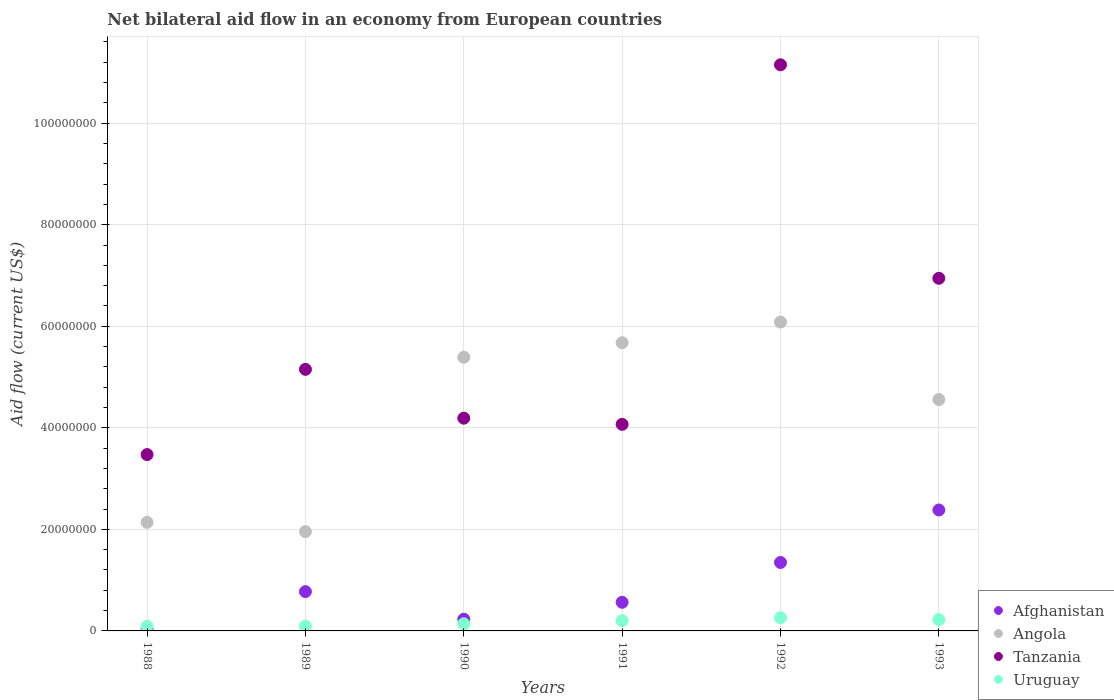Is the number of dotlines equal to the number of legend labels?
Offer a very short reply. Yes. What is the net bilateral aid flow in Angola in 1992?
Your answer should be compact. 6.08e+07. Across all years, what is the maximum net bilateral aid flow in Angola?
Provide a short and direct response. 6.08e+07. Across all years, what is the minimum net bilateral aid flow in Afghanistan?
Keep it short and to the point. 3.30e+05. In which year was the net bilateral aid flow in Uruguay minimum?
Offer a terse response. 1988. What is the total net bilateral aid flow in Angola in the graph?
Offer a very short reply. 2.58e+08. What is the difference between the net bilateral aid flow in Afghanistan in 1990 and that in 1991?
Provide a short and direct response. -3.34e+06. What is the difference between the net bilateral aid flow in Uruguay in 1988 and the net bilateral aid flow in Afghanistan in 1989?
Offer a terse response. -6.82e+06. What is the average net bilateral aid flow in Uruguay per year?
Provide a succinct answer. 1.68e+06. In the year 1992, what is the difference between the net bilateral aid flow in Angola and net bilateral aid flow in Tanzania?
Provide a succinct answer. -5.07e+07. In how many years, is the net bilateral aid flow in Tanzania greater than 28000000 US$?
Your answer should be very brief. 6. What is the ratio of the net bilateral aid flow in Tanzania in 1988 to that in 1992?
Your answer should be compact. 0.31. Is the net bilateral aid flow in Uruguay in 1992 less than that in 1993?
Your answer should be very brief. No. What is the difference between the highest and the second highest net bilateral aid flow in Afghanistan?
Provide a succinct answer. 1.03e+07. What is the difference between the highest and the lowest net bilateral aid flow in Tanzania?
Ensure brevity in your answer.  7.68e+07. Is the sum of the net bilateral aid flow in Afghanistan in 1989 and 1993 greater than the maximum net bilateral aid flow in Uruguay across all years?
Offer a terse response. Yes. Is it the case that in every year, the sum of the net bilateral aid flow in Afghanistan and net bilateral aid flow in Uruguay  is greater than the sum of net bilateral aid flow in Angola and net bilateral aid flow in Tanzania?
Offer a very short reply. No. Is it the case that in every year, the sum of the net bilateral aid flow in Tanzania and net bilateral aid flow in Angola  is greater than the net bilateral aid flow in Afghanistan?
Make the answer very short. Yes. Is the net bilateral aid flow in Uruguay strictly greater than the net bilateral aid flow in Tanzania over the years?
Provide a short and direct response. No. Is the net bilateral aid flow in Tanzania strictly less than the net bilateral aid flow in Afghanistan over the years?
Ensure brevity in your answer.  No. How many dotlines are there?
Provide a succinct answer. 4. How many years are there in the graph?
Offer a terse response. 6. What is the difference between two consecutive major ticks on the Y-axis?
Offer a terse response. 2.00e+07. Does the graph contain grids?
Your answer should be compact. Yes. Where does the legend appear in the graph?
Provide a short and direct response. Bottom right. What is the title of the graph?
Make the answer very short. Net bilateral aid flow in an economy from European countries. Does "Haiti" appear as one of the legend labels in the graph?
Your answer should be compact. No. What is the label or title of the Y-axis?
Your response must be concise. Aid flow (current US$). What is the Aid flow (current US$) in Angola in 1988?
Make the answer very short. 2.14e+07. What is the Aid flow (current US$) of Tanzania in 1988?
Offer a very short reply. 3.47e+07. What is the Aid flow (current US$) of Uruguay in 1988?
Your response must be concise. 9.20e+05. What is the Aid flow (current US$) in Afghanistan in 1989?
Provide a short and direct response. 7.74e+06. What is the Aid flow (current US$) in Angola in 1989?
Offer a very short reply. 1.96e+07. What is the Aid flow (current US$) in Tanzania in 1989?
Your answer should be very brief. 5.15e+07. What is the Aid flow (current US$) of Uruguay in 1989?
Your response must be concise. 9.50e+05. What is the Aid flow (current US$) of Afghanistan in 1990?
Offer a very short reply. 2.30e+06. What is the Aid flow (current US$) of Angola in 1990?
Ensure brevity in your answer.  5.39e+07. What is the Aid flow (current US$) in Tanzania in 1990?
Your answer should be compact. 4.19e+07. What is the Aid flow (current US$) in Uruguay in 1990?
Your answer should be very brief. 1.40e+06. What is the Aid flow (current US$) of Afghanistan in 1991?
Provide a short and direct response. 5.64e+06. What is the Aid flow (current US$) in Angola in 1991?
Ensure brevity in your answer.  5.68e+07. What is the Aid flow (current US$) in Tanzania in 1991?
Ensure brevity in your answer.  4.07e+07. What is the Aid flow (current US$) in Uruguay in 1991?
Keep it short and to the point. 2.02e+06. What is the Aid flow (current US$) of Afghanistan in 1992?
Ensure brevity in your answer.  1.35e+07. What is the Aid flow (current US$) in Angola in 1992?
Give a very brief answer. 6.08e+07. What is the Aid flow (current US$) of Tanzania in 1992?
Make the answer very short. 1.12e+08. What is the Aid flow (current US$) in Uruguay in 1992?
Your response must be concise. 2.59e+06. What is the Aid flow (current US$) of Afghanistan in 1993?
Offer a terse response. 2.38e+07. What is the Aid flow (current US$) in Angola in 1993?
Keep it short and to the point. 4.56e+07. What is the Aid flow (current US$) of Tanzania in 1993?
Provide a succinct answer. 6.94e+07. What is the Aid flow (current US$) in Uruguay in 1993?
Ensure brevity in your answer.  2.23e+06. Across all years, what is the maximum Aid flow (current US$) of Afghanistan?
Your answer should be very brief. 2.38e+07. Across all years, what is the maximum Aid flow (current US$) in Angola?
Offer a terse response. 6.08e+07. Across all years, what is the maximum Aid flow (current US$) in Tanzania?
Provide a short and direct response. 1.12e+08. Across all years, what is the maximum Aid flow (current US$) of Uruguay?
Your response must be concise. 2.59e+06. Across all years, what is the minimum Aid flow (current US$) of Afghanistan?
Your response must be concise. 3.30e+05. Across all years, what is the minimum Aid flow (current US$) of Angola?
Offer a terse response. 1.96e+07. Across all years, what is the minimum Aid flow (current US$) in Tanzania?
Offer a very short reply. 3.47e+07. Across all years, what is the minimum Aid flow (current US$) in Uruguay?
Offer a terse response. 9.20e+05. What is the total Aid flow (current US$) in Afghanistan in the graph?
Your answer should be very brief. 5.33e+07. What is the total Aid flow (current US$) of Angola in the graph?
Offer a terse response. 2.58e+08. What is the total Aid flow (current US$) in Tanzania in the graph?
Ensure brevity in your answer.  3.50e+08. What is the total Aid flow (current US$) of Uruguay in the graph?
Keep it short and to the point. 1.01e+07. What is the difference between the Aid flow (current US$) in Afghanistan in 1988 and that in 1989?
Make the answer very short. -7.41e+06. What is the difference between the Aid flow (current US$) in Angola in 1988 and that in 1989?
Your answer should be very brief. 1.82e+06. What is the difference between the Aid flow (current US$) in Tanzania in 1988 and that in 1989?
Ensure brevity in your answer.  -1.68e+07. What is the difference between the Aid flow (current US$) in Afghanistan in 1988 and that in 1990?
Ensure brevity in your answer.  -1.97e+06. What is the difference between the Aid flow (current US$) of Angola in 1988 and that in 1990?
Your response must be concise. -3.25e+07. What is the difference between the Aid flow (current US$) of Tanzania in 1988 and that in 1990?
Your response must be concise. -7.17e+06. What is the difference between the Aid flow (current US$) in Uruguay in 1988 and that in 1990?
Ensure brevity in your answer.  -4.80e+05. What is the difference between the Aid flow (current US$) of Afghanistan in 1988 and that in 1991?
Keep it short and to the point. -5.31e+06. What is the difference between the Aid flow (current US$) of Angola in 1988 and that in 1991?
Provide a succinct answer. -3.54e+07. What is the difference between the Aid flow (current US$) of Tanzania in 1988 and that in 1991?
Ensure brevity in your answer.  -5.96e+06. What is the difference between the Aid flow (current US$) of Uruguay in 1988 and that in 1991?
Offer a terse response. -1.10e+06. What is the difference between the Aid flow (current US$) of Afghanistan in 1988 and that in 1992?
Give a very brief answer. -1.32e+07. What is the difference between the Aid flow (current US$) in Angola in 1988 and that in 1992?
Offer a very short reply. -3.94e+07. What is the difference between the Aid flow (current US$) of Tanzania in 1988 and that in 1992?
Provide a succinct answer. -7.68e+07. What is the difference between the Aid flow (current US$) in Uruguay in 1988 and that in 1992?
Ensure brevity in your answer.  -1.67e+06. What is the difference between the Aid flow (current US$) of Afghanistan in 1988 and that in 1993?
Make the answer very short. -2.35e+07. What is the difference between the Aid flow (current US$) of Angola in 1988 and that in 1993?
Make the answer very short. -2.42e+07. What is the difference between the Aid flow (current US$) of Tanzania in 1988 and that in 1993?
Offer a terse response. -3.47e+07. What is the difference between the Aid flow (current US$) of Uruguay in 1988 and that in 1993?
Your response must be concise. -1.31e+06. What is the difference between the Aid flow (current US$) in Afghanistan in 1989 and that in 1990?
Make the answer very short. 5.44e+06. What is the difference between the Aid flow (current US$) of Angola in 1989 and that in 1990?
Your answer should be compact. -3.43e+07. What is the difference between the Aid flow (current US$) of Tanzania in 1989 and that in 1990?
Offer a very short reply. 9.62e+06. What is the difference between the Aid flow (current US$) of Uruguay in 1989 and that in 1990?
Make the answer very short. -4.50e+05. What is the difference between the Aid flow (current US$) of Afghanistan in 1989 and that in 1991?
Make the answer very short. 2.10e+06. What is the difference between the Aid flow (current US$) of Angola in 1989 and that in 1991?
Offer a very short reply. -3.72e+07. What is the difference between the Aid flow (current US$) in Tanzania in 1989 and that in 1991?
Offer a terse response. 1.08e+07. What is the difference between the Aid flow (current US$) in Uruguay in 1989 and that in 1991?
Make the answer very short. -1.07e+06. What is the difference between the Aid flow (current US$) in Afghanistan in 1989 and that in 1992?
Give a very brief answer. -5.74e+06. What is the difference between the Aid flow (current US$) of Angola in 1989 and that in 1992?
Give a very brief answer. -4.13e+07. What is the difference between the Aid flow (current US$) of Tanzania in 1989 and that in 1992?
Offer a terse response. -6.00e+07. What is the difference between the Aid flow (current US$) of Uruguay in 1989 and that in 1992?
Your response must be concise. -1.64e+06. What is the difference between the Aid flow (current US$) in Afghanistan in 1989 and that in 1993?
Offer a terse response. -1.61e+07. What is the difference between the Aid flow (current US$) of Angola in 1989 and that in 1993?
Ensure brevity in your answer.  -2.60e+07. What is the difference between the Aid flow (current US$) in Tanzania in 1989 and that in 1993?
Ensure brevity in your answer.  -1.79e+07. What is the difference between the Aid flow (current US$) of Uruguay in 1989 and that in 1993?
Your response must be concise. -1.28e+06. What is the difference between the Aid flow (current US$) in Afghanistan in 1990 and that in 1991?
Your answer should be very brief. -3.34e+06. What is the difference between the Aid flow (current US$) of Angola in 1990 and that in 1991?
Keep it short and to the point. -2.86e+06. What is the difference between the Aid flow (current US$) of Tanzania in 1990 and that in 1991?
Your response must be concise. 1.21e+06. What is the difference between the Aid flow (current US$) of Uruguay in 1990 and that in 1991?
Keep it short and to the point. -6.20e+05. What is the difference between the Aid flow (current US$) of Afghanistan in 1990 and that in 1992?
Offer a terse response. -1.12e+07. What is the difference between the Aid flow (current US$) in Angola in 1990 and that in 1992?
Offer a very short reply. -6.93e+06. What is the difference between the Aid flow (current US$) of Tanzania in 1990 and that in 1992?
Your answer should be compact. -6.96e+07. What is the difference between the Aid flow (current US$) of Uruguay in 1990 and that in 1992?
Your answer should be compact. -1.19e+06. What is the difference between the Aid flow (current US$) in Afghanistan in 1990 and that in 1993?
Offer a terse response. -2.15e+07. What is the difference between the Aid flow (current US$) in Angola in 1990 and that in 1993?
Make the answer very short. 8.33e+06. What is the difference between the Aid flow (current US$) of Tanzania in 1990 and that in 1993?
Offer a terse response. -2.76e+07. What is the difference between the Aid flow (current US$) of Uruguay in 1990 and that in 1993?
Provide a short and direct response. -8.30e+05. What is the difference between the Aid flow (current US$) in Afghanistan in 1991 and that in 1992?
Give a very brief answer. -7.84e+06. What is the difference between the Aid flow (current US$) of Angola in 1991 and that in 1992?
Ensure brevity in your answer.  -4.07e+06. What is the difference between the Aid flow (current US$) in Tanzania in 1991 and that in 1992?
Keep it short and to the point. -7.08e+07. What is the difference between the Aid flow (current US$) of Uruguay in 1991 and that in 1992?
Give a very brief answer. -5.70e+05. What is the difference between the Aid flow (current US$) in Afghanistan in 1991 and that in 1993?
Your response must be concise. -1.82e+07. What is the difference between the Aid flow (current US$) of Angola in 1991 and that in 1993?
Make the answer very short. 1.12e+07. What is the difference between the Aid flow (current US$) of Tanzania in 1991 and that in 1993?
Ensure brevity in your answer.  -2.88e+07. What is the difference between the Aid flow (current US$) of Uruguay in 1991 and that in 1993?
Keep it short and to the point. -2.10e+05. What is the difference between the Aid flow (current US$) in Afghanistan in 1992 and that in 1993?
Provide a short and direct response. -1.03e+07. What is the difference between the Aid flow (current US$) in Angola in 1992 and that in 1993?
Your answer should be compact. 1.53e+07. What is the difference between the Aid flow (current US$) in Tanzania in 1992 and that in 1993?
Give a very brief answer. 4.20e+07. What is the difference between the Aid flow (current US$) in Uruguay in 1992 and that in 1993?
Your answer should be compact. 3.60e+05. What is the difference between the Aid flow (current US$) of Afghanistan in 1988 and the Aid flow (current US$) of Angola in 1989?
Provide a succinct answer. -1.92e+07. What is the difference between the Aid flow (current US$) of Afghanistan in 1988 and the Aid flow (current US$) of Tanzania in 1989?
Give a very brief answer. -5.12e+07. What is the difference between the Aid flow (current US$) of Afghanistan in 1988 and the Aid flow (current US$) of Uruguay in 1989?
Offer a very short reply. -6.20e+05. What is the difference between the Aid flow (current US$) of Angola in 1988 and the Aid flow (current US$) of Tanzania in 1989?
Give a very brief answer. -3.01e+07. What is the difference between the Aid flow (current US$) of Angola in 1988 and the Aid flow (current US$) of Uruguay in 1989?
Offer a very short reply. 2.04e+07. What is the difference between the Aid flow (current US$) of Tanzania in 1988 and the Aid flow (current US$) of Uruguay in 1989?
Make the answer very short. 3.38e+07. What is the difference between the Aid flow (current US$) of Afghanistan in 1988 and the Aid flow (current US$) of Angola in 1990?
Offer a terse response. -5.36e+07. What is the difference between the Aid flow (current US$) of Afghanistan in 1988 and the Aid flow (current US$) of Tanzania in 1990?
Provide a succinct answer. -4.16e+07. What is the difference between the Aid flow (current US$) of Afghanistan in 1988 and the Aid flow (current US$) of Uruguay in 1990?
Offer a terse response. -1.07e+06. What is the difference between the Aid flow (current US$) of Angola in 1988 and the Aid flow (current US$) of Tanzania in 1990?
Ensure brevity in your answer.  -2.05e+07. What is the difference between the Aid flow (current US$) in Angola in 1988 and the Aid flow (current US$) in Uruguay in 1990?
Provide a succinct answer. 2.00e+07. What is the difference between the Aid flow (current US$) of Tanzania in 1988 and the Aid flow (current US$) of Uruguay in 1990?
Provide a short and direct response. 3.33e+07. What is the difference between the Aid flow (current US$) of Afghanistan in 1988 and the Aid flow (current US$) of Angola in 1991?
Offer a very short reply. -5.64e+07. What is the difference between the Aid flow (current US$) of Afghanistan in 1988 and the Aid flow (current US$) of Tanzania in 1991?
Provide a short and direct response. -4.04e+07. What is the difference between the Aid flow (current US$) in Afghanistan in 1988 and the Aid flow (current US$) in Uruguay in 1991?
Provide a succinct answer. -1.69e+06. What is the difference between the Aid flow (current US$) in Angola in 1988 and the Aid flow (current US$) in Tanzania in 1991?
Offer a terse response. -1.93e+07. What is the difference between the Aid flow (current US$) in Angola in 1988 and the Aid flow (current US$) in Uruguay in 1991?
Keep it short and to the point. 1.94e+07. What is the difference between the Aid flow (current US$) in Tanzania in 1988 and the Aid flow (current US$) in Uruguay in 1991?
Provide a succinct answer. 3.27e+07. What is the difference between the Aid flow (current US$) in Afghanistan in 1988 and the Aid flow (current US$) in Angola in 1992?
Ensure brevity in your answer.  -6.05e+07. What is the difference between the Aid flow (current US$) in Afghanistan in 1988 and the Aid flow (current US$) in Tanzania in 1992?
Give a very brief answer. -1.11e+08. What is the difference between the Aid flow (current US$) of Afghanistan in 1988 and the Aid flow (current US$) of Uruguay in 1992?
Your answer should be very brief. -2.26e+06. What is the difference between the Aid flow (current US$) of Angola in 1988 and the Aid flow (current US$) of Tanzania in 1992?
Make the answer very short. -9.01e+07. What is the difference between the Aid flow (current US$) of Angola in 1988 and the Aid flow (current US$) of Uruguay in 1992?
Offer a terse response. 1.88e+07. What is the difference between the Aid flow (current US$) of Tanzania in 1988 and the Aid flow (current US$) of Uruguay in 1992?
Ensure brevity in your answer.  3.21e+07. What is the difference between the Aid flow (current US$) of Afghanistan in 1988 and the Aid flow (current US$) of Angola in 1993?
Your answer should be very brief. -4.52e+07. What is the difference between the Aid flow (current US$) of Afghanistan in 1988 and the Aid flow (current US$) of Tanzania in 1993?
Your response must be concise. -6.91e+07. What is the difference between the Aid flow (current US$) of Afghanistan in 1988 and the Aid flow (current US$) of Uruguay in 1993?
Provide a succinct answer. -1.90e+06. What is the difference between the Aid flow (current US$) of Angola in 1988 and the Aid flow (current US$) of Tanzania in 1993?
Your answer should be compact. -4.81e+07. What is the difference between the Aid flow (current US$) of Angola in 1988 and the Aid flow (current US$) of Uruguay in 1993?
Provide a short and direct response. 1.92e+07. What is the difference between the Aid flow (current US$) in Tanzania in 1988 and the Aid flow (current US$) in Uruguay in 1993?
Provide a short and direct response. 3.25e+07. What is the difference between the Aid flow (current US$) of Afghanistan in 1989 and the Aid flow (current US$) of Angola in 1990?
Give a very brief answer. -4.62e+07. What is the difference between the Aid flow (current US$) in Afghanistan in 1989 and the Aid flow (current US$) in Tanzania in 1990?
Your answer should be compact. -3.42e+07. What is the difference between the Aid flow (current US$) of Afghanistan in 1989 and the Aid flow (current US$) of Uruguay in 1990?
Your answer should be compact. 6.34e+06. What is the difference between the Aid flow (current US$) in Angola in 1989 and the Aid flow (current US$) in Tanzania in 1990?
Ensure brevity in your answer.  -2.23e+07. What is the difference between the Aid flow (current US$) in Angola in 1989 and the Aid flow (current US$) in Uruguay in 1990?
Your answer should be compact. 1.82e+07. What is the difference between the Aid flow (current US$) in Tanzania in 1989 and the Aid flow (current US$) in Uruguay in 1990?
Your answer should be compact. 5.01e+07. What is the difference between the Aid flow (current US$) in Afghanistan in 1989 and the Aid flow (current US$) in Angola in 1991?
Make the answer very short. -4.90e+07. What is the difference between the Aid flow (current US$) of Afghanistan in 1989 and the Aid flow (current US$) of Tanzania in 1991?
Give a very brief answer. -3.30e+07. What is the difference between the Aid flow (current US$) in Afghanistan in 1989 and the Aid flow (current US$) in Uruguay in 1991?
Your response must be concise. 5.72e+06. What is the difference between the Aid flow (current US$) of Angola in 1989 and the Aid flow (current US$) of Tanzania in 1991?
Your response must be concise. -2.11e+07. What is the difference between the Aid flow (current US$) in Angola in 1989 and the Aid flow (current US$) in Uruguay in 1991?
Make the answer very short. 1.75e+07. What is the difference between the Aid flow (current US$) in Tanzania in 1989 and the Aid flow (current US$) in Uruguay in 1991?
Give a very brief answer. 4.95e+07. What is the difference between the Aid flow (current US$) in Afghanistan in 1989 and the Aid flow (current US$) in Angola in 1992?
Your response must be concise. -5.31e+07. What is the difference between the Aid flow (current US$) in Afghanistan in 1989 and the Aid flow (current US$) in Tanzania in 1992?
Your answer should be compact. -1.04e+08. What is the difference between the Aid flow (current US$) in Afghanistan in 1989 and the Aid flow (current US$) in Uruguay in 1992?
Your answer should be very brief. 5.15e+06. What is the difference between the Aid flow (current US$) of Angola in 1989 and the Aid flow (current US$) of Tanzania in 1992?
Provide a succinct answer. -9.19e+07. What is the difference between the Aid flow (current US$) of Angola in 1989 and the Aid flow (current US$) of Uruguay in 1992?
Your answer should be very brief. 1.70e+07. What is the difference between the Aid flow (current US$) in Tanzania in 1989 and the Aid flow (current US$) in Uruguay in 1992?
Offer a very short reply. 4.89e+07. What is the difference between the Aid flow (current US$) in Afghanistan in 1989 and the Aid flow (current US$) in Angola in 1993?
Provide a succinct answer. -3.78e+07. What is the difference between the Aid flow (current US$) in Afghanistan in 1989 and the Aid flow (current US$) in Tanzania in 1993?
Your answer should be very brief. -6.17e+07. What is the difference between the Aid flow (current US$) in Afghanistan in 1989 and the Aid flow (current US$) in Uruguay in 1993?
Your answer should be very brief. 5.51e+06. What is the difference between the Aid flow (current US$) of Angola in 1989 and the Aid flow (current US$) of Tanzania in 1993?
Make the answer very short. -4.99e+07. What is the difference between the Aid flow (current US$) in Angola in 1989 and the Aid flow (current US$) in Uruguay in 1993?
Your response must be concise. 1.73e+07. What is the difference between the Aid flow (current US$) of Tanzania in 1989 and the Aid flow (current US$) of Uruguay in 1993?
Ensure brevity in your answer.  4.93e+07. What is the difference between the Aid flow (current US$) of Afghanistan in 1990 and the Aid flow (current US$) of Angola in 1991?
Offer a very short reply. -5.45e+07. What is the difference between the Aid flow (current US$) in Afghanistan in 1990 and the Aid flow (current US$) in Tanzania in 1991?
Ensure brevity in your answer.  -3.84e+07. What is the difference between the Aid flow (current US$) in Afghanistan in 1990 and the Aid flow (current US$) in Uruguay in 1991?
Provide a succinct answer. 2.80e+05. What is the difference between the Aid flow (current US$) in Angola in 1990 and the Aid flow (current US$) in Tanzania in 1991?
Provide a succinct answer. 1.32e+07. What is the difference between the Aid flow (current US$) of Angola in 1990 and the Aid flow (current US$) of Uruguay in 1991?
Offer a very short reply. 5.19e+07. What is the difference between the Aid flow (current US$) in Tanzania in 1990 and the Aid flow (current US$) in Uruguay in 1991?
Keep it short and to the point. 3.99e+07. What is the difference between the Aid flow (current US$) of Afghanistan in 1990 and the Aid flow (current US$) of Angola in 1992?
Keep it short and to the point. -5.85e+07. What is the difference between the Aid flow (current US$) of Afghanistan in 1990 and the Aid flow (current US$) of Tanzania in 1992?
Your answer should be compact. -1.09e+08. What is the difference between the Aid flow (current US$) of Afghanistan in 1990 and the Aid flow (current US$) of Uruguay in 1992?
Offer a terse response. -2.90e+05. What is the difference between the Aid flow (current US$) of Angola in 1990 and the Aid flow (current US$) of Tanzania in 1992?
Provide a short and direct response. -5.76e+07. What is the difference between the Aid flow (current US$) in Angola in 1990 and the Aid flow (current US$) in Uruguay in 1992?
Provide a short and direct response. 5.13e+07. What is the difference between the Aid flow (current US$) of Tanzania in 1990 and the Aid flow (current US$) of Uruguay in 1992?
Your answer should be very brief. 3.93e+07. What is the difference between the Aid flow (current US$) in Afghanistan in 1990 and the Aid flow (current US$) in Angola in 1993?
Make the answer very short. -4.33e+07. What is the difference between the Aid flow (current US$) in Afghanistan in 1990 and the Aid flow (current US$) in Tanzania in 1993?
Offer a very short reply. -6.72e+07. What is the difference between the Aid flow (current US$) in Afghanistan in 1990 and the Aid flow (current US$) in Uruguay in 1993?
Provide a succinct answer. 7.00e+04. What is the difference between the Aid flow (current US$) in Angola in 1990 and the Aid flow (current US$) in Tanzania in 1993?
Provide a succinct answer. -1.56e+07. What is the difference between the Aid flow (current US$) in Angola in 1990 and the Aid flow (current US$) in Uruguay in 1993?
Your answer should be compact. 5.17e+07. What is the difference between the Aid flow (current US$) of Tanzania in 1990 and the Aid flow (current US$) of Uruguay in 1993?
Make the answer very short. 3.97e+07. What is the difference between the Aid flow (current US$) of Afghanistan in 1991 and the Aid flow (current US$) of Angola in 1992?
Make the answer very short. -5.52e+07. What is the difference between the Aid flow (current US$) of Afghanistan in 1991 and the Aid flow (current US$) of Tanzania in 1992?
Your response must be concise. -1.06e+08. What is the difference between the Aid flow (current US$) of Afghanistan in 1991 and the Aid flow (current US$) of Uruguay in 1992?
Offer a very short reply. 3.05e+06. What is the difference between the Aid flow (current US$) of Angola in 1991 and the Aid flow (current US$) of Tanzania in 1992?
Offer a very short reply. -5.47e+07. What is the difference between the Aid flow (current US$) of Angola in 1991 and the Aid flow (current US$) of Uruguay in 1992?
Your answer should be compact. 5.42e+07. What is the difference between the Aid flow (current US$) in Tanzania in 1991 and the Aid flow (current US$) in Uruguay in 1992?
Your response must be concise. 3.81e+07. What is the difference between the Aid flow (current US$) of Afghanistan in 1991 and the Aid flow (current US$) of Angola in 1993?
Provide a succinct answer. -3.99e+07. What is the difference between the Aid flow (current US$) in Afghanistan in 1991 and the Aid flow (current US$) in Tanzania in 1993?
Offer a very short reply. -6.38e+07. What is the difference between the Aid flow (current US$) in Afghanistan in 1991 and the Aid flow (current US$) in Uruguay in 1993?
Provide a short and direct response. 3.41e+06. What is the difference between the Aid flow (current US$) in Angola in 1991 and the Aid flow (current US$) in Tanzania in 1993?
Your answer should be compact. -1.27e+07. What is the difference between the Aid flow (current US$) in Angola in 1991 and the Aid flow (current US$) in Uruguay in 1993?
Keep it short and to the point. 5.45e+07. What is the difference between the Aid flow (current US$) of Tanzania in 1991 and the Aid flow (current US$) of Uruguay in 1993?
Ensure brevity in your answer.  3.85e+07. What is the difference between the Aid flow (current US$) in Afghanistan in 1992 and the Aid flow (current US$) in Angola in 1993?
Your response must be concise. -3.21e+07. What is the difference between the Aid flow (current US$) of Afghanistan in 1992 and the Aid flow (current US$) of Tanzania in 1993?
Ensure brevity in your answer.  -5.60e+07. What is the difference between the Aid flow (current US$) of Afghanistan in 1992 and the Aid flow (current US$) of Uruguay in 1993?
Offer a terse response. 1.12e+07. What is the difference between the Aid flow (current US$) of Angola in 1992 and the Aid flow (current US$) of Tanzania in 1993?
Give a very brief answer. -8.62e+06. What is the difference between the Aid flow (current US$) of Angola in 1992 and the Aid flow (current US$) of Uruguay in 1993?
Provide a succinct answer. 5.86e+07. What is the difference between the Aid flow (current US$) in Tanzania in 1992 and the Aid flow (current US$) in Uruguay in 1993?
Your answer should be compact. 1.09e+08. What is the average Aid flow (current US$) of Afghanistan per year?
Your answer should be compact. 8.88e+06. What is the average Aid flow (current US$) of Angola per year?
Give a very brief answer. 4.30e+07. What is the average Aid flow (current US$) in Tanzania per year?
Make the answer very short. 5.83e+07. What is the average Aid flow (current US$) in Uruguay per year?
Provide a succinct answer. 1.68e+06. In the year 1988, what is the difference between the Aid flow (current US$) of Afghanistan and Aid flow (current US$) of Angola?
Your response must be concise. -2.10e+07. In the year 1988, what is the difference between the Aid flow (current US$) of Afghanistan and Aid flow (current US$) of Tanzania?
Provide a succinct answer. -3.44e+07. In the year 1988, what is the difference between the Aid flow (current US$) of Afghanistan and Aid flow (current US$) of Uruguay?
Your answer should be compact. -5.90e+05. In the year 1988, what is the difference between the Aid flow (current US$) of Angola and Aid flow (current US$) of Tanzania?
Give a very brief answer. -1.34e+07. In the year 1988, what is the difference between the Aid flow (current US$) of Angola and Aid flow (current US$) of Uruguay?
Keep it short and to the point. 2.05e+07. In the year 1988, what is the difference between the Aid flow (current US$) of Tanzania and Aid flow (current US$) of Uruguay?
Your answer should be very brief. 3.38e+07. In the year 1989, what is the difference between the Aid flow (current US$) of Afghanistan and Aid flow (current US$) of Angola?
Keep it short and to the point. -1.18e+07. In the year 1989, what is the difference between the Aid flow (current US$) of Afghanistan and Aid flow (current US$) of Tanzania?
Provide a succinct answer. -4.38e+07. In the year 1989, what is the difference between the Aid flow (current US$) in Afghanistan and Aid flow (current US$) in Uruguay?
Your response must be concise. 6.79e+06. In the year 1989, what is the difference between the Aid flow (current US$) of Angola and Aid flow (current US$) of Tanzania?
Give a very brief answer. -3.20e+07. In the year 1989, what is the difference between the Aid flow (current US$) of Angola and Aid flow (current US$) of Uruguay?
Offer a very short reply. 1.86e+07. In the year 1989, what is the difference between the Aid flow (current US$) in Tanzania and Aid flow (current US$) in Uruguay?
Make the answer very short. 5.06e+07. In the year 1990, what is the difference between the Aid flow (current US$) in Afghanistan and Aid flow (current US$) in Angola?
Your answer should be compact. -5.16e+07. In the year 1990, what is the difference between the Aid flow (current US$) of Afghanistan and Aid flow (current US$) of Tanzania?
Your answer should be compact. -3.96e+07. In the year 1990, what is the difference between the Aid flow (current US$) of Afghanistan and Aid flow (current US$) of Uruguay?
Give a very brief answer. 9.00e+05. In the year 1990, what is the difference between the Aid flow (current US$) in Angola and Aid flow (current US$) in Uruguay?
Offer a very short reply. 5.25e+07. In the year 1990, what is the difference between the Aid flow (current US$) of Tanzania and Aid flow (current US$) of Uruguay?
Provide a short and direct response. 4.05e+07. In the year 1991, what is the difference between the Aid flow (current US$) in Afghanistan and Aid flow (current US$) in Angola?
Provide a succinct answer. -5.11e+07. In the year 1991, what is the difference between the Aid flow (current US$) of Afghanistan and Aid flow (current US$) of Tanzania?
Keep it short and to the point. -3.50e+07. In the year 1991, what is the difference between the Aid flow (current US$) in Afghanistan and Aid flow (current US$) in Uruguay?
Offer a terse response. 3.62e+06. In the year 1991, what is the difference between the Aid flow (current US$) in Angola and Aid flow (current US$) in Tanzania?
Provide a succinct answer. 1.61e+07. In the year 1991, what is the difference between the Aid flow (current US$) in Angola and Aid flow (current US$) in Uruguay?
Offer a very short reply. 5.47e+07. In the year 1991, what is the difference between the Aid flow (current US$) of Tanzania and Aid flow (current US$) of Uruguay?
Ensure brevity in your answer.  3.87e+07. In the year 1992, what is the difference between the Aid flow (current US$) of Afghanistan and Aid flow (current US$) of Angola?
Provide a succinct answer. -4.74e+07. In the year 1992, what is the difference between the Aid flow (current US$) of Afghanistan and Aid flow (current US$) of Tanzania?
Ensure brevity in your answer.  -9.80e+07. In the year 1992, what is the difference between the Aid flow (current US$) of Afghanistan and Aid flow (current US$) of Uruguay?
Provide a short and direct response. 1.09e+07. In the year 1992, what is the difference between the Aid flow (current US$) of Angola and Aid flow (current US$) of Tanzania?
Keep it short and to the point. -5.07e+07. In the year 1992, what is the difference between the Aid flow (current US$) of Angola and Aid flow (current US$) of Uruguay?
Give a very brief answer. 5.82e+07. In the year 1992, what is the difference between the Aid flow (current US$) in Tanzania and Aid flow (current US$) in Uruguay?
Ensure brevity in your answer.  1.09e+08. In the year 1993, what is the difference between the Aid flow (current US$) of Afghanistan and Aid flow (current US$) of Angola?
Give a very brief answer. -2.18e+07. In the year 1993, what is the difference between the Aid flow (current US$) of Afghanistan and Aid flow (current US$) of Tanzania?
Your response must be concise. -4.56e+07. In the year 1993, what is the difference between the Aid flow (current US$) in Afghanistan and Aid flow (current US$) in Uruguay?
Give a very brief answer. 2.16e+07. In the year 1993, what is the difference between the Aid flow (current US$) of Angola and Aid flow (current US$) of Tanzania?
Your response must be concise. -2.39e+07. In the year 1993, what is the difference between the Aid flow (current US$) of Angola and Aid flow (current US$) of Uruguay?
Provide a short and direct response. 4.33e+07. In the year 1993, what is the difference between the Aid flow (current US$) in Tanzania and Aid flow (current US$) in Uruguay?
Make the answer very short. 6.72e+07. What is the ratio of the Aid flow (current US$) in Afghanistan in 1988 to that in 1989?
Your answer should be very brief. 0.04. What is the ratio of the Aid flow (current US$) of Angola in 1988 to that in 1989?
Your response must be concise. 1.09. What is the ratio of the Aid flow (current US$) in Tanzania in 1988 to that in 1989?
Provide a succinct answer. 0.67. What is the ratio of the Aid flow (current US$) of Uruguay in 1988 to that in 1989?
Ensure brevity in your answer.  0.97. What is the ratio of the Aid flow (current US$) in Afghanistan in 1988 to that in 1990?
Your response must be concise. 0.14. What is the ratio of the Aid flow (current US$) of Angola in 1988 to that in 1990?
Your response must be concise. 0.4. What is the ratio of the Aid flow (current US$) in Tanzania in 1988 to that in 1990?
Make the answer very short. 0.83. What is the ratio of the Aid flow (current US$) in Uruguay in 1988 to that in 1990?
Your response must be concise. 0.66. What is the ratio of the Aid flow (current US$) of Afghanistan in 1988 to that in 1991?
Give a very brief answer. 0.06. What is the ratio of the Aid flow (current US$) in Angola in 1988 to that in 1991?
Your answer should be very brief. 0.38. What is the ratio of the Aid flow (current US$) in Tanzania in 1988 to that in 1991?
Your answer should be very brief. 0.85. What is the ratio of the Aid flow (current US$) in Uruguay in 1988 to that in 1991?
Your response must be concise. 0.46. What is the ratio of the Aid flow (current US$) of Afghanistan in 1988 to that in 1992?
Your response must be concise. 0.02. What is the ratio of the Aid flow (current US$) in Angola in 1988 to that in 1992?
Provide a short and direct response. 0.35. What is the ratio of the Aid flow (current US$) in Tanzania in 1988 to that in 1992?
Offer a very short reply. 0.31. What is the ratio of the Aid flow (current US$) in Uruguay in 1988 to that in 1992?
Provide a short and direct response. 0.36. What is the ratio of the Aid flow (current US$) in Afghanistan in 1988 to that in 1993?
Offer a terse response. 0.01. What is the ratio of the Aid flow (current US$) in Angola in 1988 to that in 1993?
Ensure brevity in your answer.  0.47. What is the ratio of the Aid flow (current US$) of Tanzania in 1988 to that in 1993?
Your response must be concise. 0.5. What is the ratio of the Aid flow (current US$) in Uruguay in 1988 to that in 1993?
Give a very brief answer. 0.41. What is the ratio of the Aid flow (current US$) of Afghanistan in 1989 to that in 1990?
Give a very brief answer. 3.37. What is the ratio of the Aid flow (current US$) in Angola in 1989 to that in 1990?
Your response must be concise. 0.36. What is the ratio of the Aid flow (current US$) of Tanzania in 1989 to that in 1990?
Provide a succinct answer. 1.23. What is the ratio of the Aid flow (current US$) of Uruguay in 1989 to that in 1990?
Ensure brevity in your answer.  0.68. What is the ratio of the Aid flow (current US$) in Afghanistan in 1989 to that in 1991?
Your response must be concise. 1.37. What is the ratio of the Aid flow (current US$) of Angola in 1989 to that in 1991?
Offer a very short reply. 0.34. What is the ratio of the Aid flow (current US$) in Tanzania in 1989 to that in 1991?
Your answer should be compact. 1.27. What is the ratio of the Aid flow (current US$) of Uruguay in 1989 to that in 1991?
Keep it short and to the point. 0.47. What is the ratio of the Aid flow (current US$) of Afghanistan in 1989 to that in 1992?
Provide a short and direct response. 0.57. What is the ratio of the Aid flow (current US$) in Angola in 1989 to that in 1992?
Give a very brief answer. 0.32. What is the ratio of the Aid flow (current US$) in Tanzania in 1989 to that in 1992?
Ensure brevity in your answer.  0.46. What is the ratio of the Aid flow (current US$) in Uruguay in 1989 to that in 1992?
Offer a terse response. 0.37. What is the ratio of the Aid flow (current US$) of Afghanistan in 1989 to that in 1993?
Provide a succinct answer. 0.32. What is the ratio of the Aid flow (current US$) in Angola in 1989 to that in 1993?
Your response must be concise. 0.43. What is the ratio of the Aid flow (current US$) in Tanzania in 1989 to that in 1993?
Your answer should be very brief. 0.74. What is the ratio of the Aid flow (current US$) of Uruguay in 1989 to that in 1993?
Make the answer very short. 0.43. What is the ratio of the Aid flow (current US$) of Afghanistan in 1990 to that in 1991?
Provide a succinct answer. 0.41. What is the ratio of the Aid flow (current US$) of Angola in 1990 to that in 1991?
Provide a short and direct response. 0.95. What is the ratio of the Aid flow (current US$) in Tanzania in 1990 to that in 1991?
Keep it short and to the point. 1.03. What is the ratio of the Aid flow (current US$) in Uruguay in 1990 to that in 1991?
Your response must be concise. 0.69. What is the ratio of the Aid flow (current US$) in Afghanistan in 1990 to that in 1992?
Your answer should be compact. 0.17. What is the ratio of the Aid flow (current US$) in Angola in 1990 to that in 1992?
Provide a short and direct response. 0.89. What is the ratio of the Aid flow (current US$) in Tanzania in 1990 to that in 1992?
Ensure brevity in your answer.  0.38. What is the ratio of the Aid flow (current US$) in Uruguay in 1990 to that in 1992?
Make the answer very short. 0.54. What is the ratio of the Aid flow (current US$) of Afghanistan in 1990 to that in 1993?
Make the answer very short. 0.1. What is the ratio of the Aid flow (current US$) of Angola in 1990 to that in 1993?
Your response must be concise. 1.18. What is the ratio of the Aid flow (current US$) in Tanzania in 1990 to that in 1993?
Ensure brevity in your answer.  0.6. What is the ratio of the Aid flow (current US$) in Uruguay in 1990 to that in 1993?
Ensure brevity in your answer.  0.63. What is the ratio of the Aid flow (current US$) of Afghanistan in 1991 to that in 1992?
Offer a very short reply. 0.42. What is the ratio of the Aid flow (current US$) in Angola in 1991 to that in 1992?
Keep it short and to the point. 0.93. What is the ratio of the Aid flow (current US$) of Tanzania in 1991 to that in 1992?
Provide a succinct answer. 0.36. What is the ratio of the Aid flow (current US$) in Uruguay in 1991 to that in 1992?
Offer a very short reply. 0.78. What is the ratio of the Aid flow (current US$) of Afghanistan in 1991 to that in 1993?
Your answer should be very brief. 0.24. What is the ratio of the Aid flow (current US$) in Angola in 1991 to that in 1993?
Your response must be concise. 1.25. What is the ratio of the Aid flow (current US$) in Tanzania in 1991 to that in 1993?
Offer a terse response. 0.59. What is the ratio of the Aid flow (current US$) of Uruguay in 1991 to that in 1993?
Make the answer very short. 0.91. What is the ratio of the Aid flow (current US$) in Afghanistan in 1992 to that in 1993?
Keep it short and to the point. 0.57. What is the ratio of the Aid flow (current US$) in Angola in 1992 to that in 1993?
Offer a terse response. 1.33. What is the ratio of the Aid flow (current US$) of Tanzania in 1992 to that in 1993?
Provide a short and direct response. 1.61. What is the ratio of the Aid flow (current US$) of Uruguay in 1992 to that in 1993?
Your answer should be very brief. 1.16. What is the difference between the highest and the second highest Aid flow (current US$) in Afghanistan?
Provide a short and direct response. 1.03e+07. What is the difference between the highest and the second highest Aid flow (current US$) of Angola?
Give a very brief answer. 4.07e+06. What is the difference between the highest and the second highest Aid flow (current US$) in Tanzania?
Ensure brevity in your answer.  4.20e+07. What is the difference between the highest and the lowest Aid flow (current US$) of Afghanistan?
Your response must be concise. 2.35e+07. What is the difference between the highest and the lowest Aid flow (current US$) of Angola?
Make the answer very short. 4.13e+07. What is the difference between the highest and the lowest Aid flow (current US$) of Tanzania?
Your response must be concise. 7.68e+07. What is the difference between the highest and the lowest Aid flow (current US$) of Uruguay?
Your answer should be compact. 1.67e+06. 